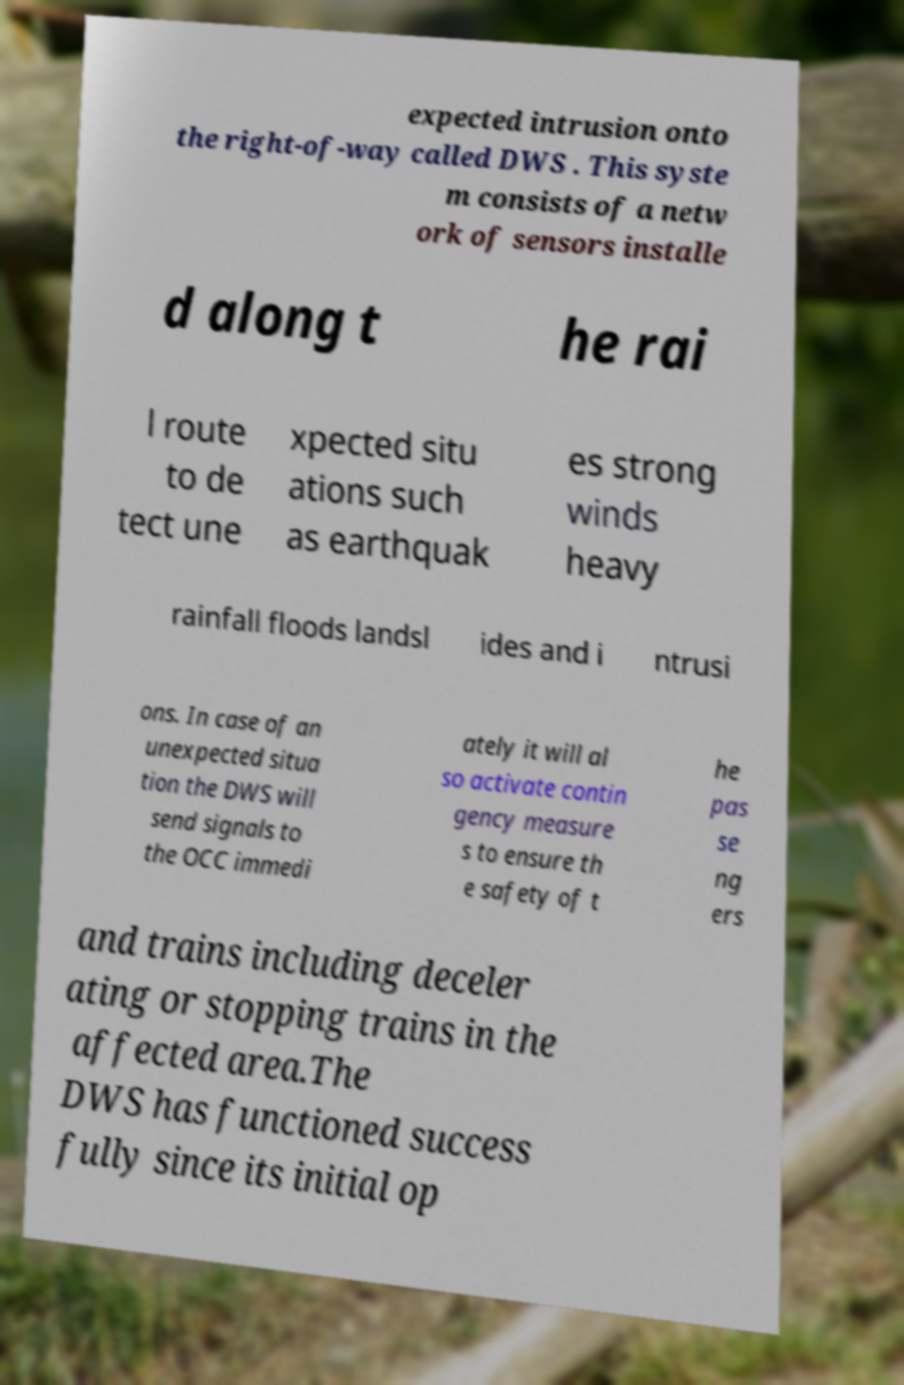What messages or text are displayed in this image? I need them in a readable, typed format. expected intrusion onto the right-of-way called DWS . This syste m consists of a netw ork of sensors installe d along t he rai l route to de tect une xpected situ ations such as earthquak es strong winds heavy rainfall floods landsl ides and i ntrusi ons. In case of an unexpected situa tion the DWS will send signals to the OCC immedi ately it will al so activate contin gency measure s to ensure th e safety of t he pas se ng ers and trains including deceler ating or stopping trains in the affected area.The DWS has functioned success fully since its initial op 